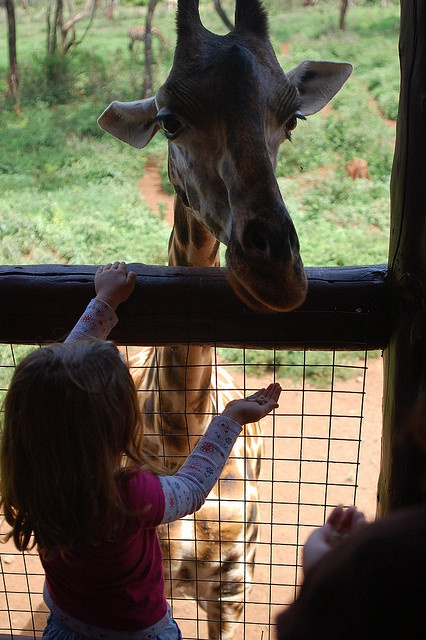Describe the objects in this image and their specific colors. I can see giraffe in gray, black, and maroon tones, people in gray, black, maroon, and purple tones, and people in gray, black, and maroon tones in this image. 